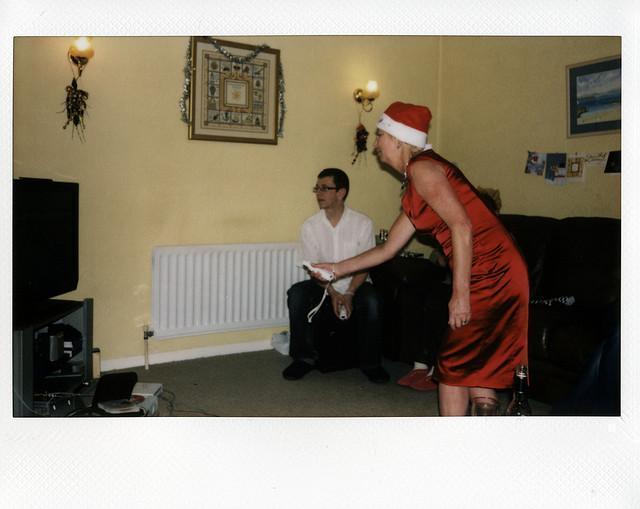What gift did the woman seen here get for Christmas?
From the following four choices, select the correct answer to address the question.
Options: White dress, wii, cook book, santa hat. Wii. 